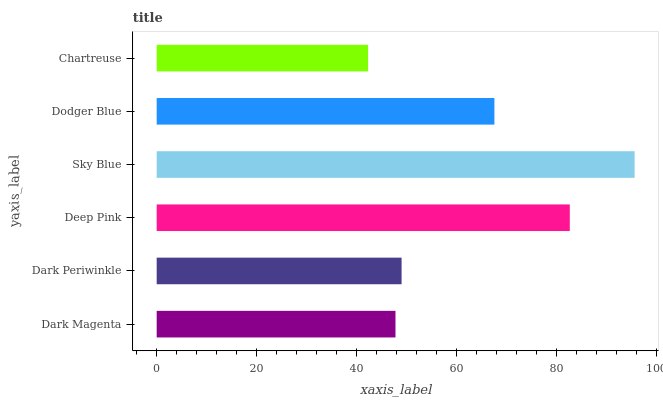Is Chartreuse the minimum?
Answer yes or no. Yes. Is Sky Blue the maximum?
Answer yes or no. Yes. Is Dark Periwinkle the minimum?
Answer yes or no. No. Is Dark Periwinkle the maximum?
Answer yes or no. No. Is Dark Periwinkle greater than Dark Magenta?
Answer yes or no. Yes. Is Dark Magenta less than Dark Periwinkle?
Answer yes or no. Yes. Is Dark Magenta greater than Dark Periwinkle?
Answer yes or no. No. Is Dark Periwinkle less than Dark Magenta?
Answer yes or no. No. Is Dodger Blue the high median?
Answer yes or no. Yes. Is Dark Periwinkle the low median?
Answer yes or no. Yes. Is Sky Blue the high median?
Answer yes or no. No. Is Dark Magenta the low median?
Answer yes or no. No. 